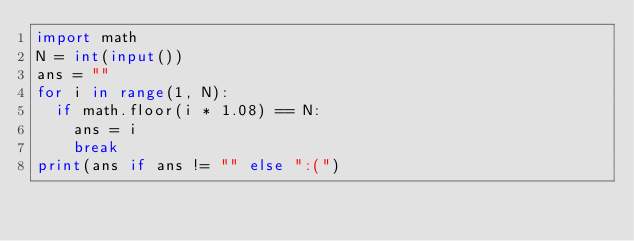<code> <loc_0><loc_0><loc_500><loc_500><_Python_>import math
N = int(input())
ans = ""
for i in range(1, N):
  if math.floor(i * 1.08) == N:
    ans = i
    break
print(ans if ans != "" else ":(")</code> 